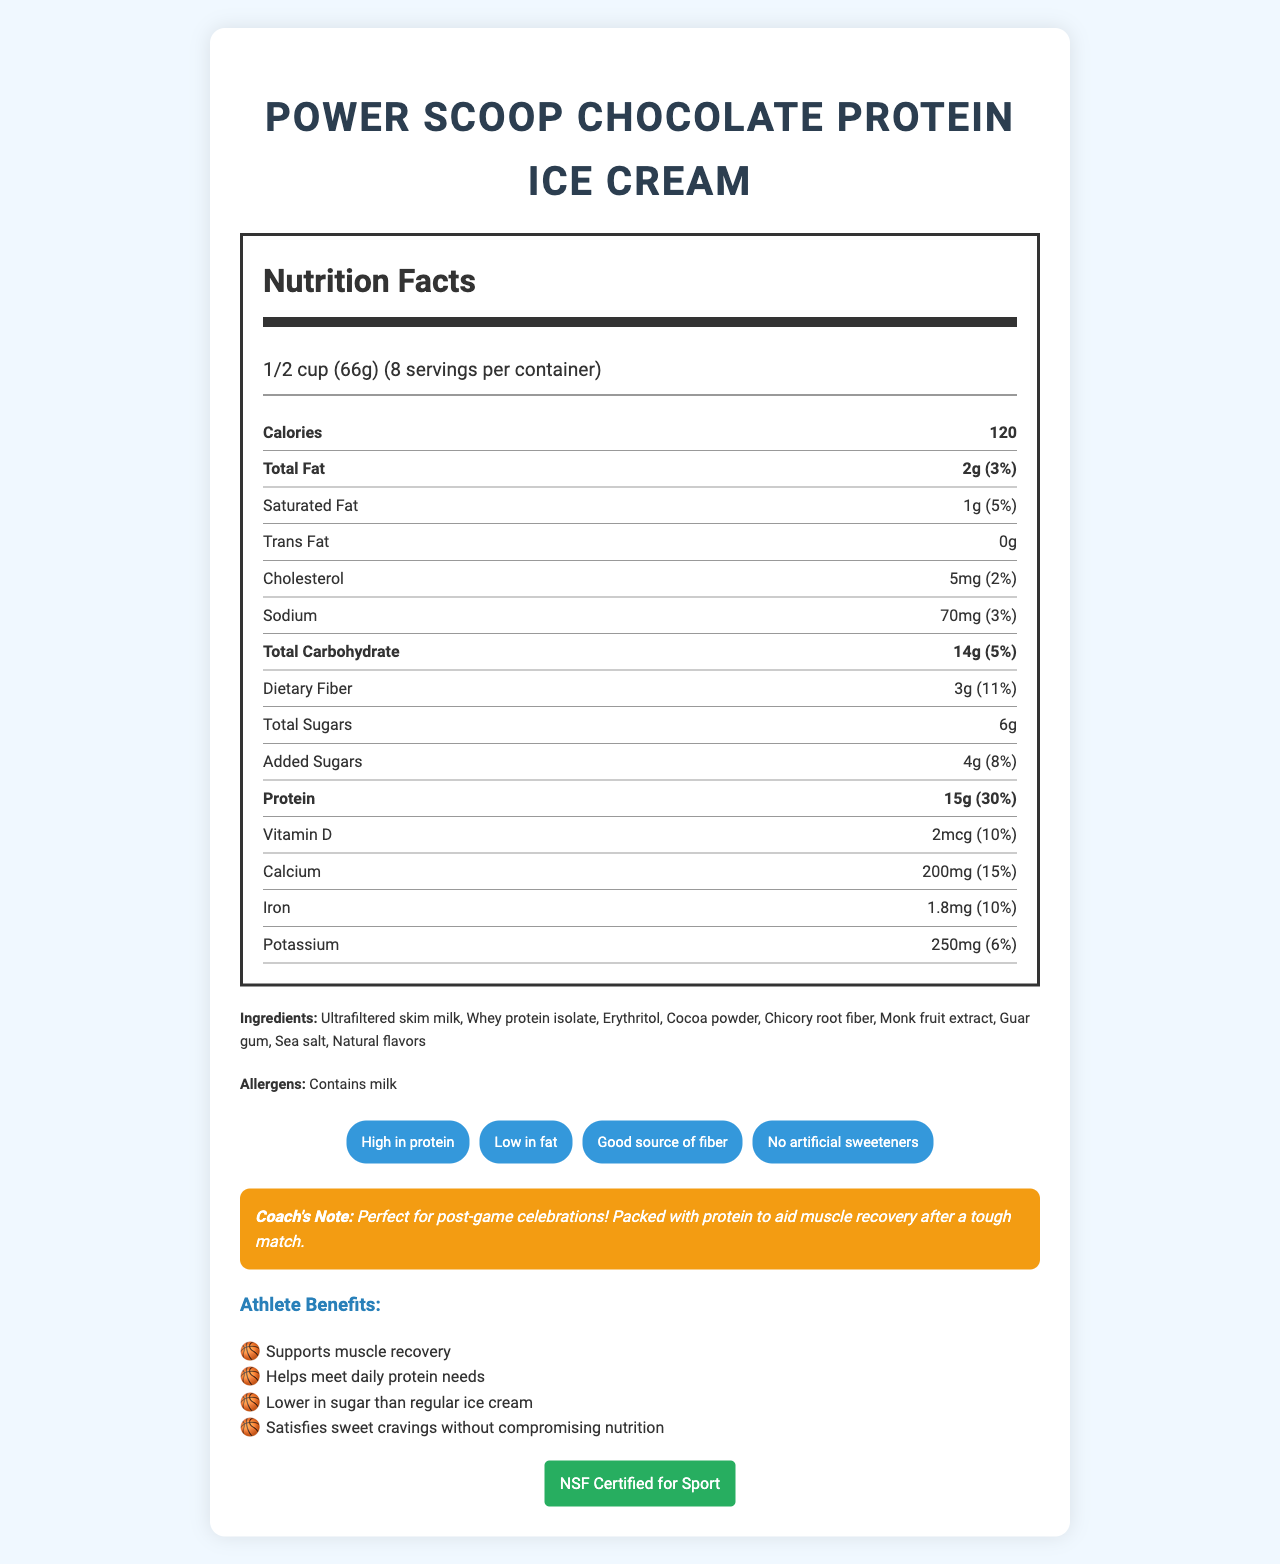what is the product name? The product name, "Power Scoop Chocolate Protein Ice Cream," is stated at the top of the document.
Answer: Power Scoop Chocolate Protein Ice Cream what is the serving size of the ice cream? The serving size, "1/2 cup (66g)," is mentioned below the title of the document.
Answer: 1/2 cup (66g) how many servings are in one container? The document lists "8 servings per container."
Answer: 8 how many calories are in one serving? The number of calories per serving is indicated as "120" in the nutrient label section.
Answer: 120 how much protein does one serving contain? The amount of protein is specified as "15g" in the nutrient table.
Answer: 15g what percentage of the daily value is the total fat per serving? The total fat's daily value is specified as "3%" in the nutrient label.
Answer: 3% what ingredients are used in the ice cream? The ingredients list includes all these components.
Answer: Ultrafiltered skim milk, Whey protein isolate, Erythritol, Cocoa powder, Chicory root fiber, Monk fruit extract, Guar gum, Sea salt, Natural flavors what certifications does the product have? The document shows "NSF Certified for Sport" as a certification.
Answer: NSF Certified for Sport is the product high in protein? The document claims "High in protein" in the claims section.
Answer: Yes is the ice cream suitable for someone trying to reduce sugar intake? The document states benefits like "Lower in sugar than regular ice cream" and the added sugars amount is specified as "4g" with a daily value of "8%".
Answer: Yes which of the following claims is NOT made about the product? A. High in protein B. Low in fat C. Contains artificial sweeteners The document claims "High in protein," "Low in fat," and specifically "No artificial sweeteners."
Answer: C. Contains artificial sweeteners which nutrient is present in the highest amount per serving? A. Protein B. Total Fat C. Carbohydrates Protein is listed as 15g, which is higher than the total fat (2g) and carbohydrates (14g).
Answer: A. Protein does the document specify the amount of Vitamin C in the product? The document does not mention Vitamin C at all.
Answer: No summarize the main information provided in the document. The document summarizes the nutritional content, ingredients, certifications, product claims, and benefits, positioning the product as suitable for athletic recovery.
Answer: The document provides detailed nutrition facts for "Power Scoop Chocolate Protein Ice Cream," highlighting its high protein content, low fat, and fiber benefits. It includes a full list of ingredients, allergens, and nutrient values per serving. Additionally, it mentions the product's certification and claims, along with a coach's note emphasizing its suitability for athletes. what is the daily value percentage of iron in one serving? The document specifies that the iron daily value per serving is 10%.
Answer: 10% how much dietary fiber is in one serving? The document lists dietary fiber as 3g per serving.
Answer: 3g how much calcium is in one serving of the product? The document specifies that one serving contains 200mg of calcium.
Answer: 200mg what is the total carbohydrate content in one serving? The total carbohydrate content per serving is indicated as 14g.
Answer: 14g can you determine the price of the ice cream from the document? The document does not provide any information regarding the price of the ice cream.
Answer: Not enough information 